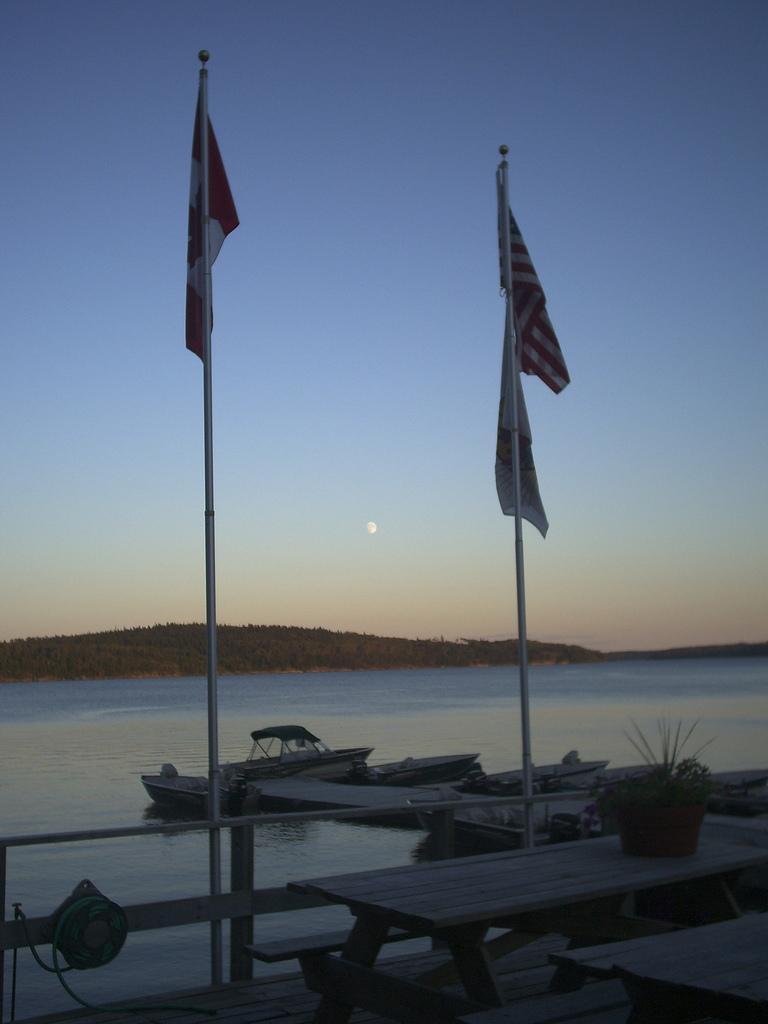Could you give a brief overview of what you see in this image? In the image we can see there are two poles on which there are flags and there is a pot of plant kept on the bench. Behind there are boats standing on the water and there is a hill covered with trees. 